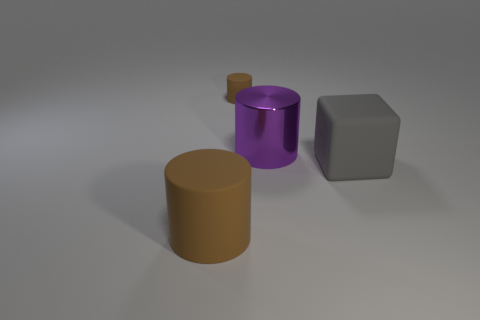Does the small object have the same color as the big matte cylinder?
Give a very brief answer. Yes. How many objects are the same color as the big metallic cylinder?
Provide a succinct answer. 0. What number of objects are big gray matte spheres or small cylinders?
Your response must be concise. 1. There is a big cylinder to the right of the matte thing that is on the left side of the small rubber object; what is its material?
Ensure brevity in your answer.  Metal. Are there any other big things that have the same material as the large brown thing?
Give a very brief answer. Yes. There is a brown rubber object that is on the left side of the brown cylinder on the right side of the large matte thing on the left side of the gray block; what shape is it?
Give a very brief answer. Cylinder. What material is the gray cube?
Keep it short and to the point. Rubber. There is a tiny cylinder that is made of the same material as the large brown thing; what color is it?
Keep it short and to the point. Brown. Are there any brown things that are left of the thing behind the purple cylinder?
Your answer should be compact. Yes. How many other things are the same shape as the gray object?
Give a very brief answer. 0. 